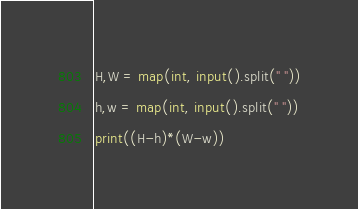<code> <loc_0><loc_0><loc_500><loc_500><_Python_>H,W = map(int, input().split(" "))
h,w = map(int, input().split(" "))
print((H-h)*(W-w))
</code> 